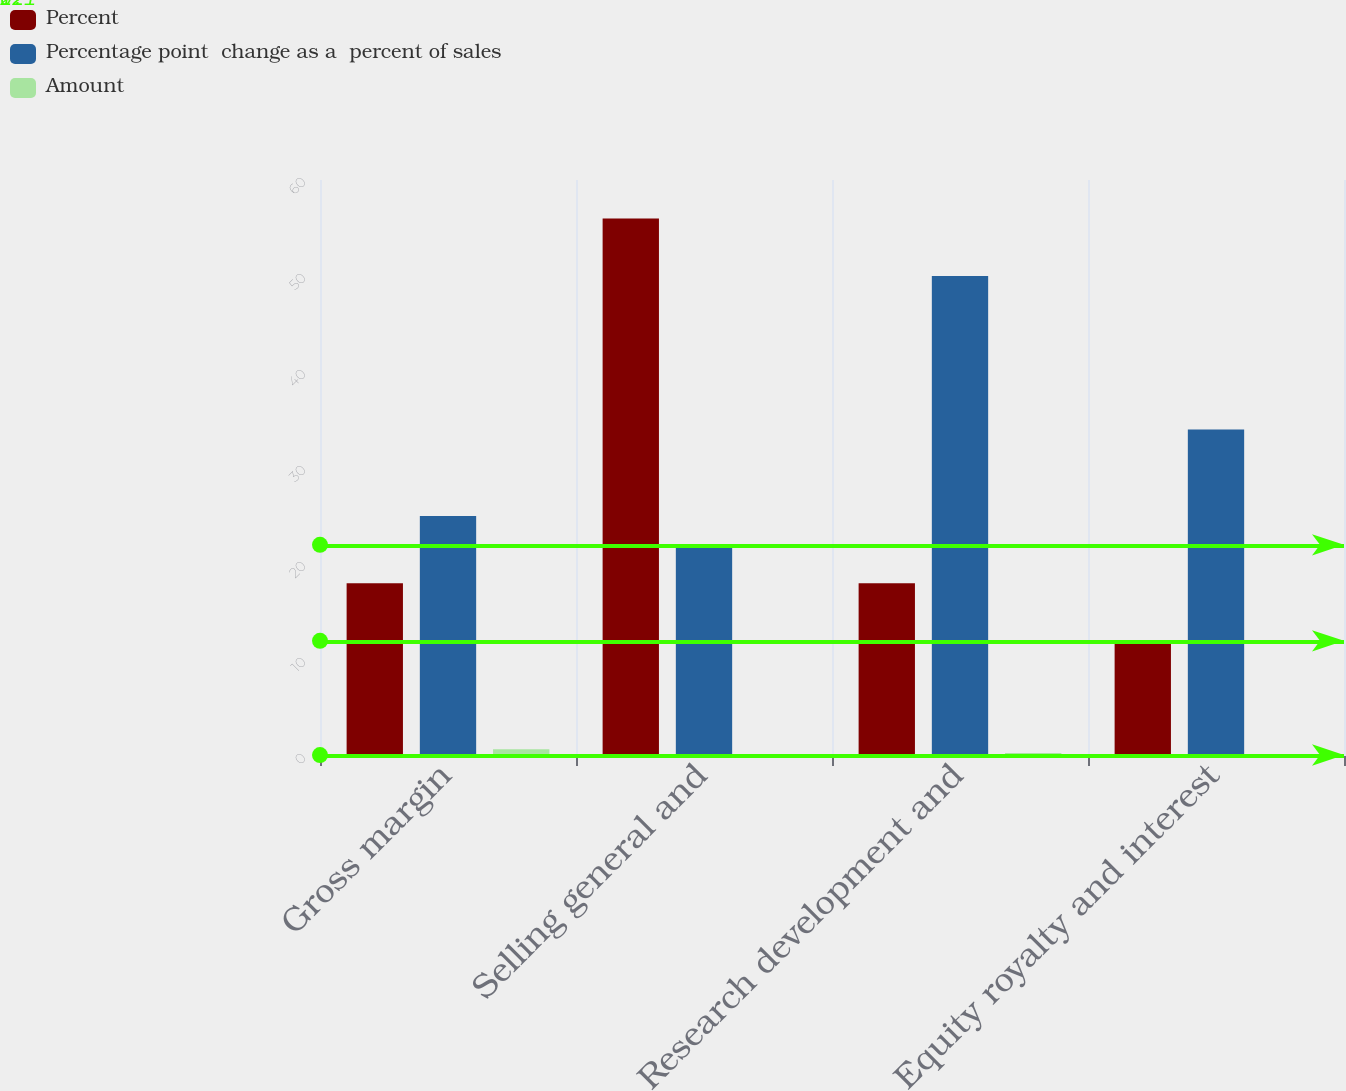<chart> <loc_0><loc_0><loc_500><loc_500><stacked_bar_chart><ecel><fcel>Gross margin<fcel>Selling general and<fcel>Research development and<fcel>Equity royalty and interest<nl><fcel>Percent<fcel>18<fcel>56<fcel>18<fcel>12<nl><fcel>Percentage point  change as a  percent of sales<fcel>25<fcel>22<fcel>50<fcel>34<nl><fcel>Amount<fcel>0.7<fcel>0.2<fcel>0.3<fcel>0.1<nl></chart> 